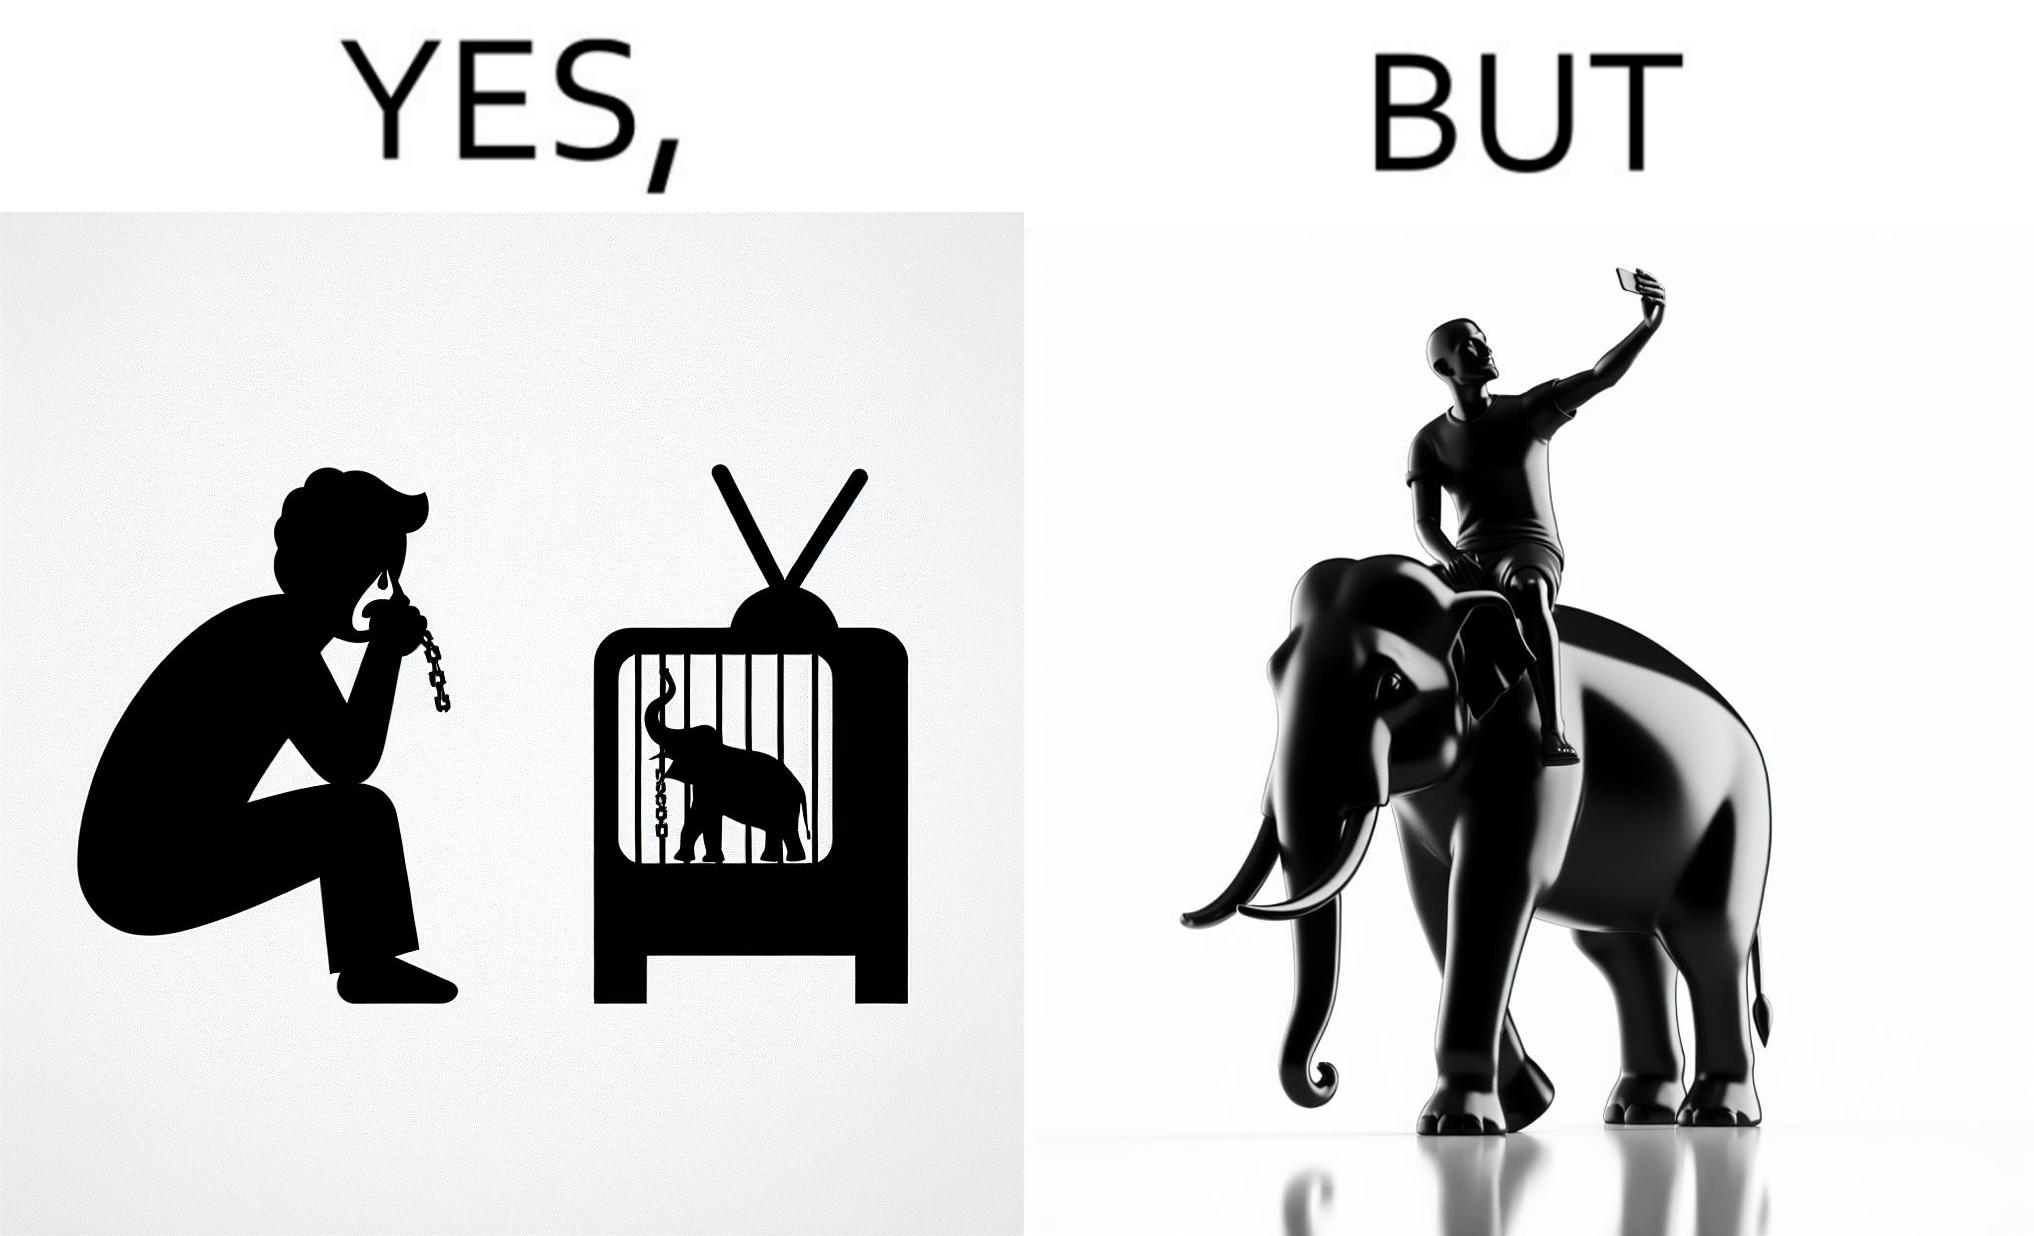Describe the contrast between the left and right parts of this image. In the left part of the image: a man crying on seeing an elephant being chained in a cage in a TV program In the right part of the image: a person riding an elephant while taking selfies 